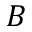<formula> <loc_0><loc_0><loc_500><loc_500>B</formula> 